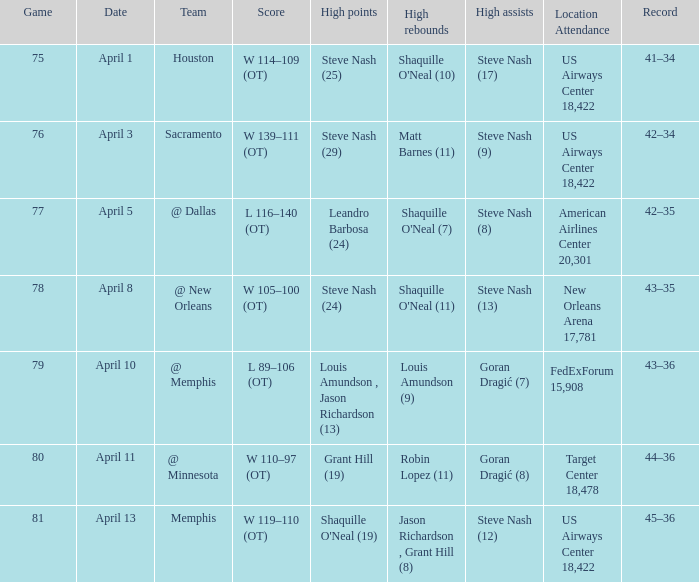Who did the most assists when Matt Barnes (11) got the most rebounds? Steve Nash (9). 